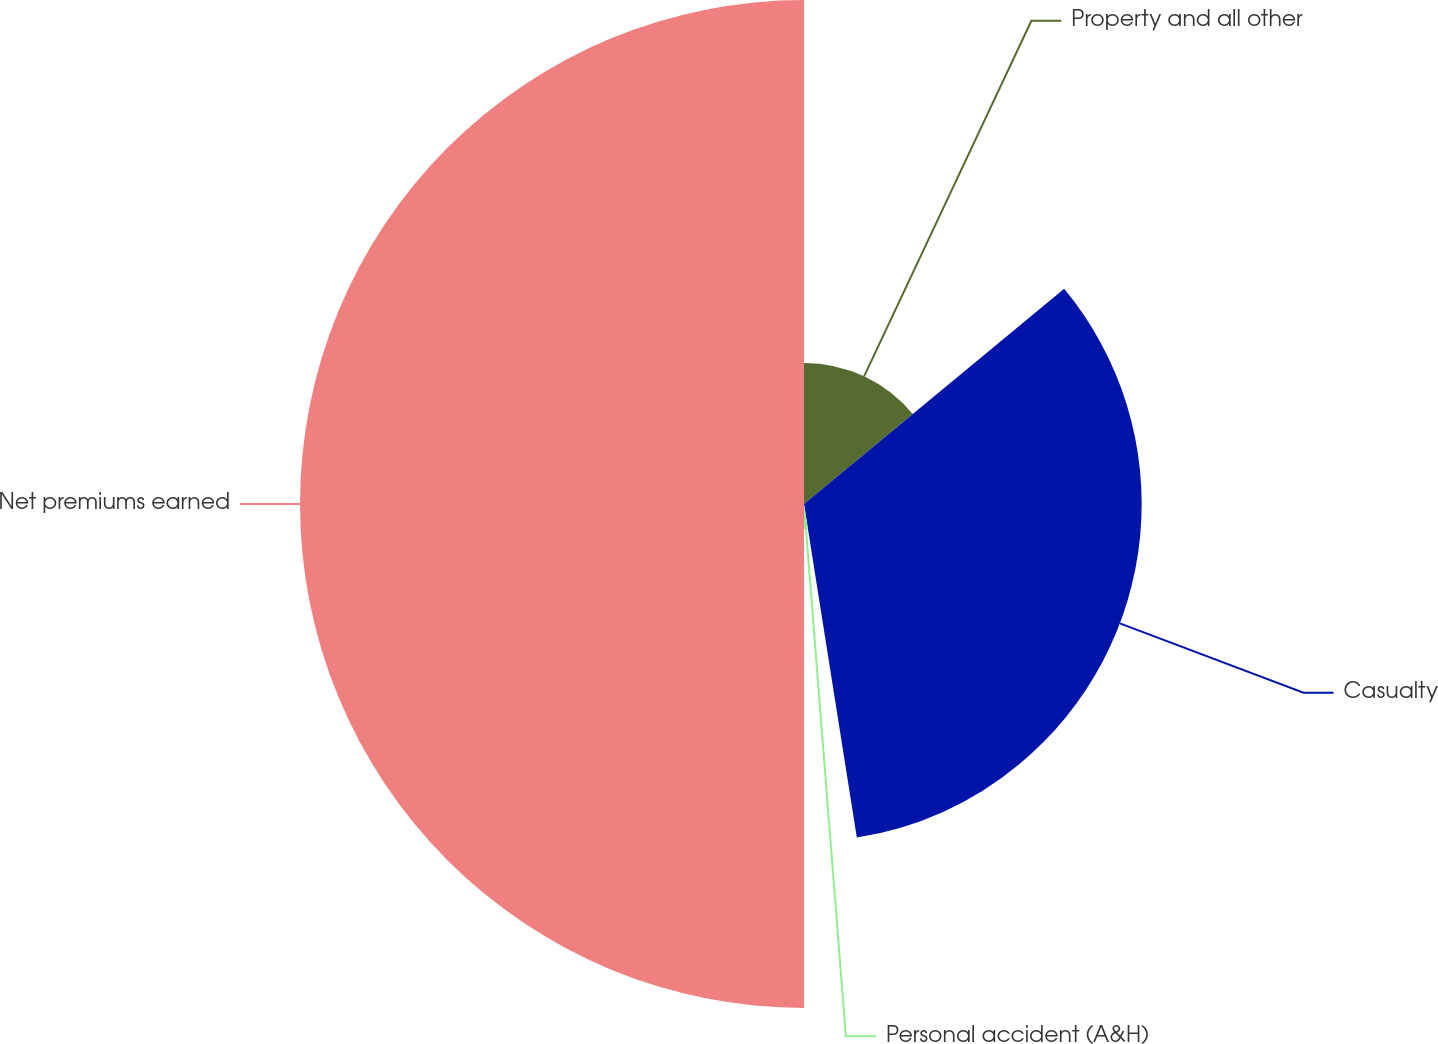Convert chart. <chart><loc_0><loc_0><loc_500><loc_500><pie_chart><fcel>Property and all other<fcel>Casualty<fcel>Personal accident (A&H)<fcel>Net premiums earned<nl><fcel>14.0%<fcel>33.5%<fcel>2.5%<fcel>50.0%<nl></chart> 